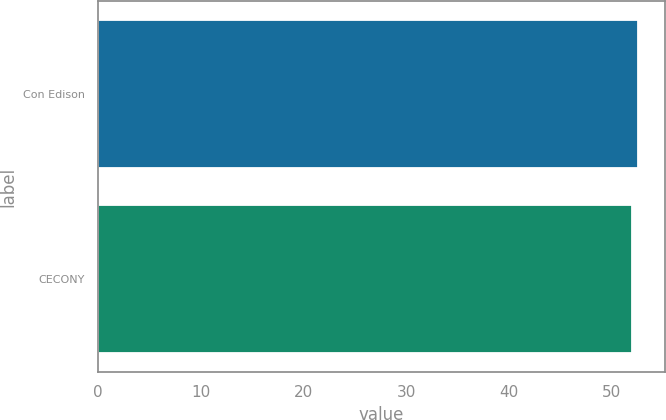Convert chart to OTSL. <chart><loc_0><loc_0><loc_500><loc_500><bar_chart><fcel>Con Edison<fcel>CECONY<nl><fcel>52.5<fcel>52<nl></chart> 